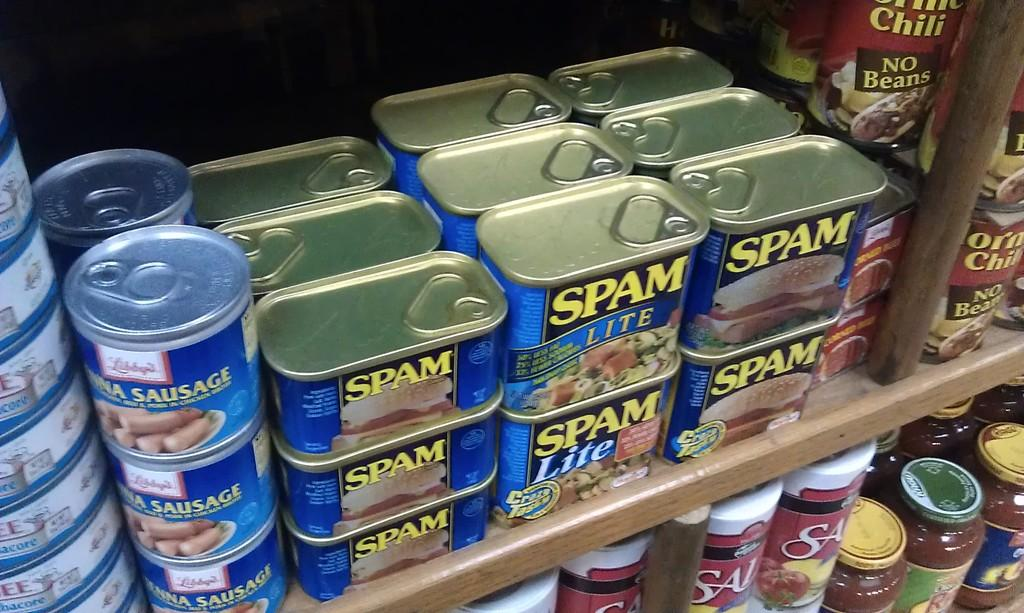<image>
Summarize the visual content of the image. Vienna Sausages are stacked together, on a shelf, next to several cans of spam that is stacked together. 